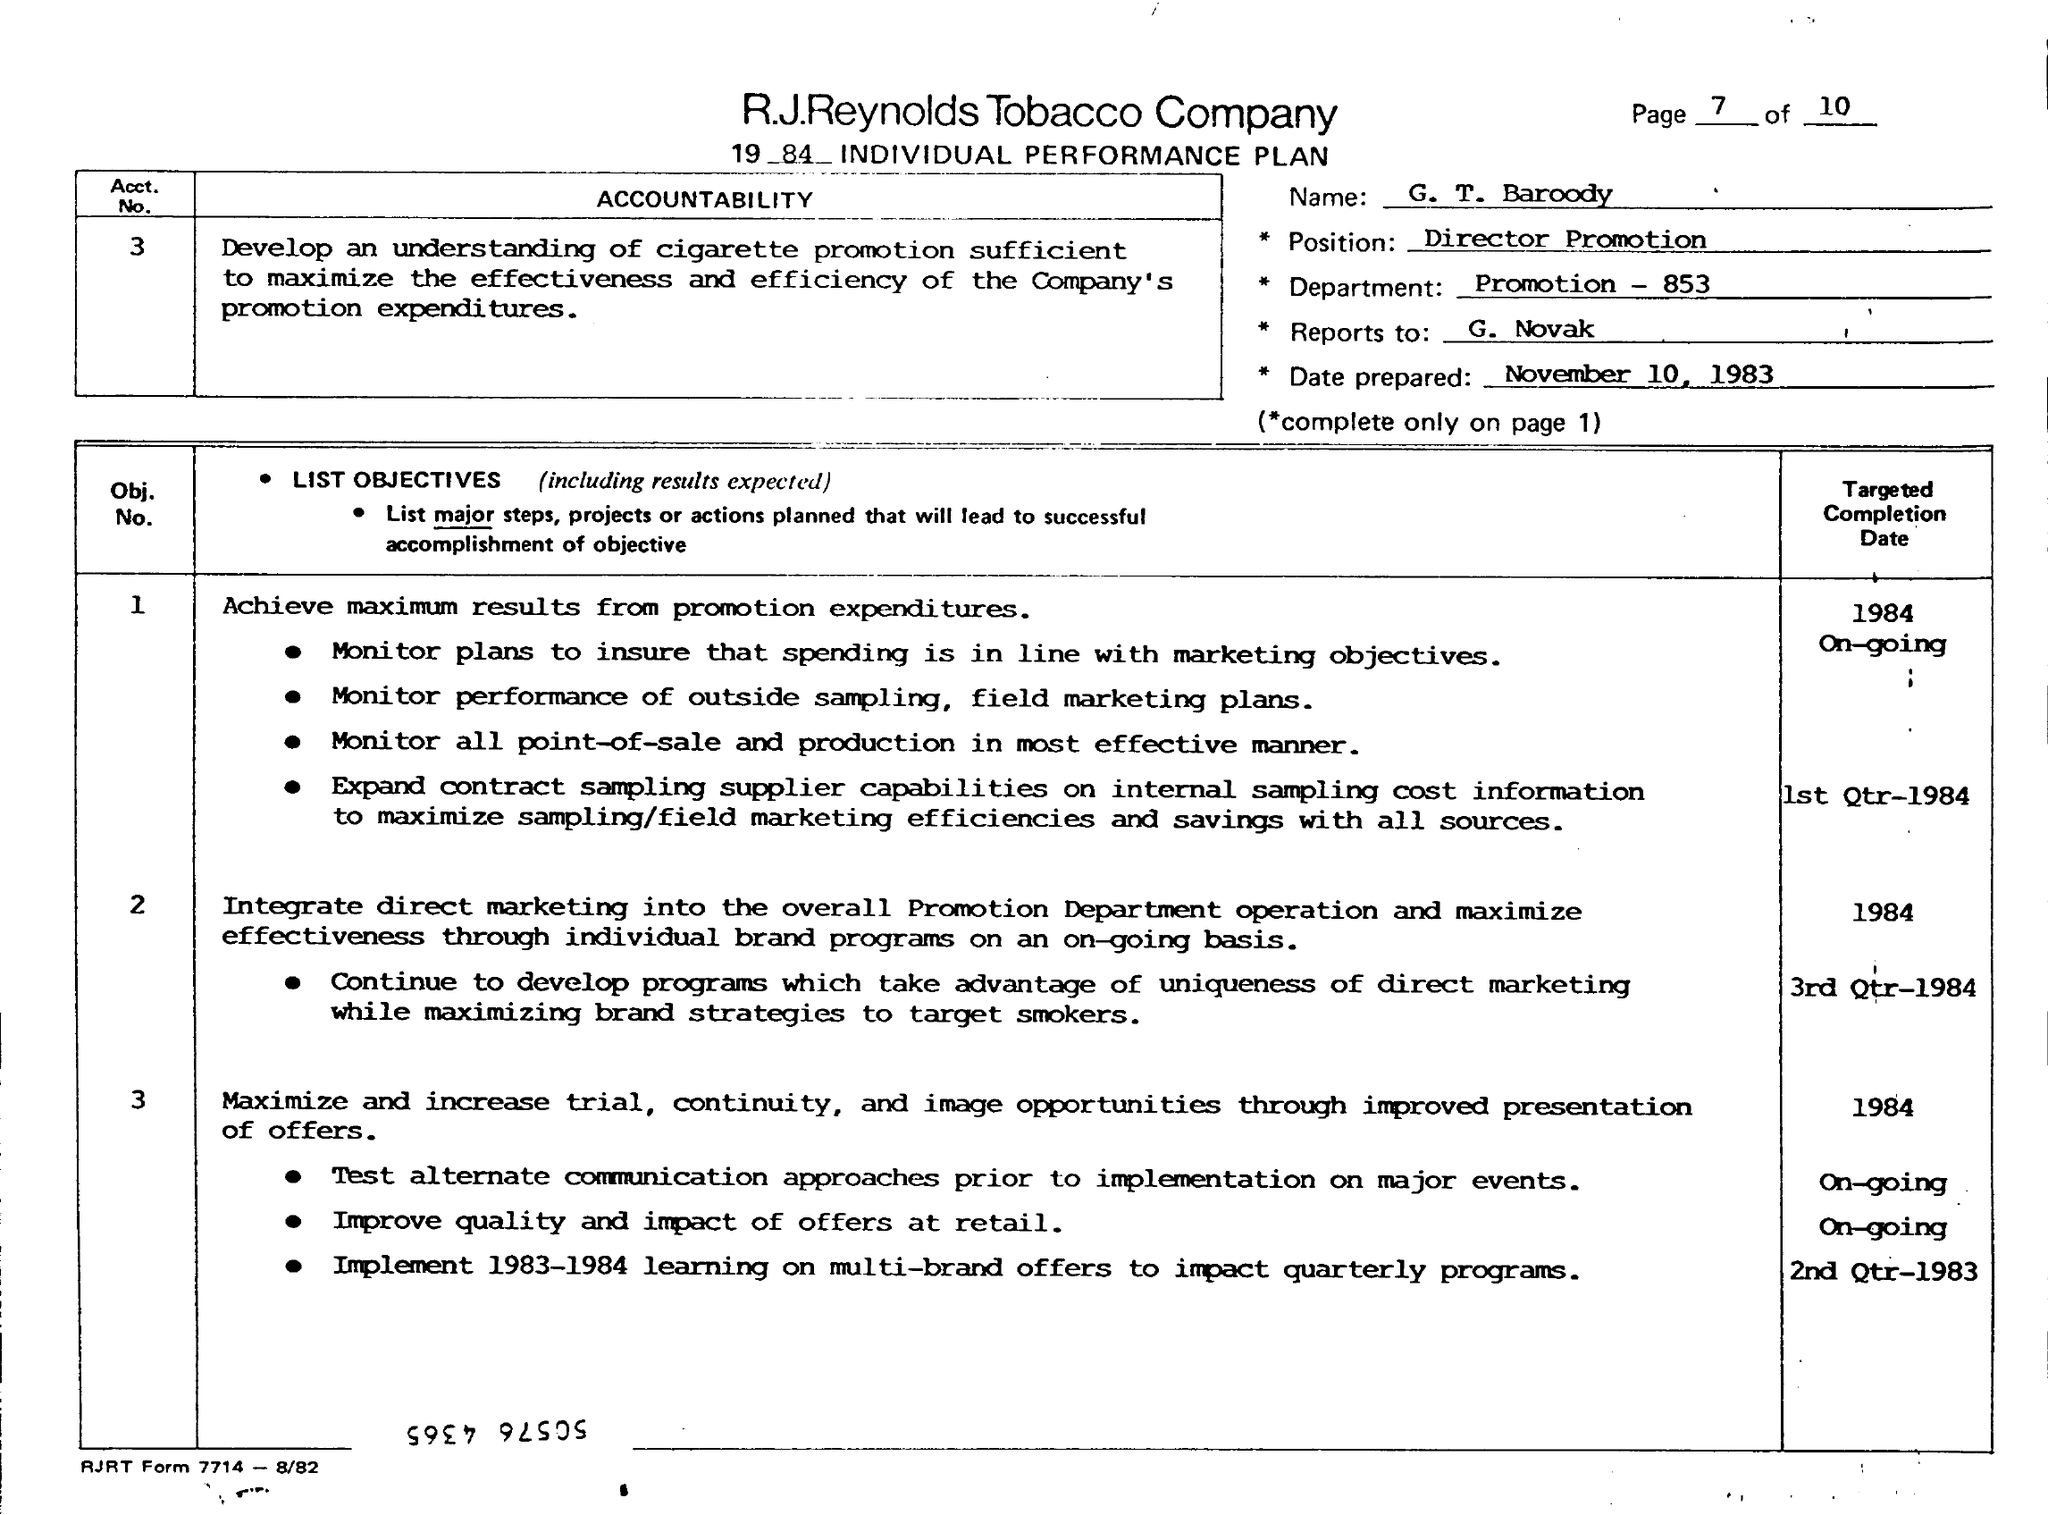What is the Name?
Your answer should be compact. G. T. Baroody. What is the Department?
Make the answer very short. Promotion - 853. What is the "Reports to"?
Provide a succinct answer. G. Novak. When is the Date Prepared?
Make the answer very short. November 10, 1983. 